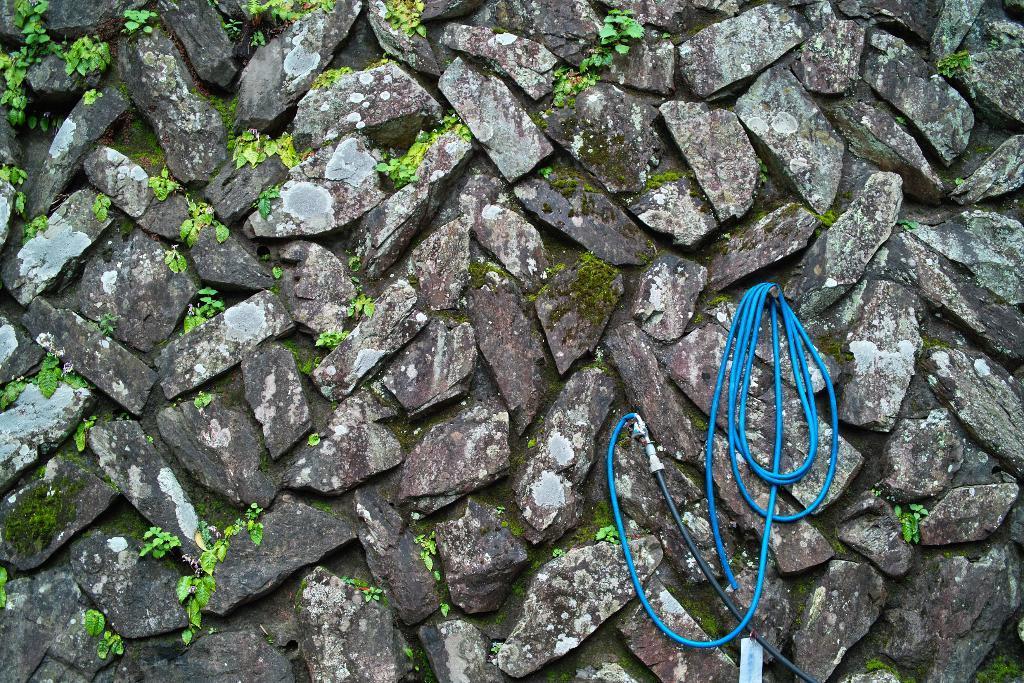Can you describe this image briefly? On the right we can see a blue color water pipe which is hanged to this nail. Here we can see some grass on this wall. 